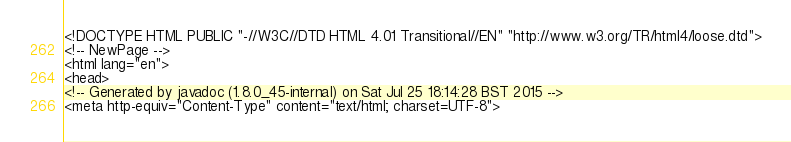<code> <loc_0><loc_0><loc_500><loc_500><_HTML_><!DOCTYPE HTML PUBLIC "-//W3C//DTD HTML 4.01 Transitional//EN" "http://www.w3.org/TR/html4/loose.dtd">
<!-- NewPage -->
<html lang="en">
<head>
<!-- Generated by javadoc (1.8.0_45-internal) on Sat Jul 25 18:14:28 BST 2015 -->
<meta http-equiv="Content-Type" content="text/html; charset=UTF-8"></code> 